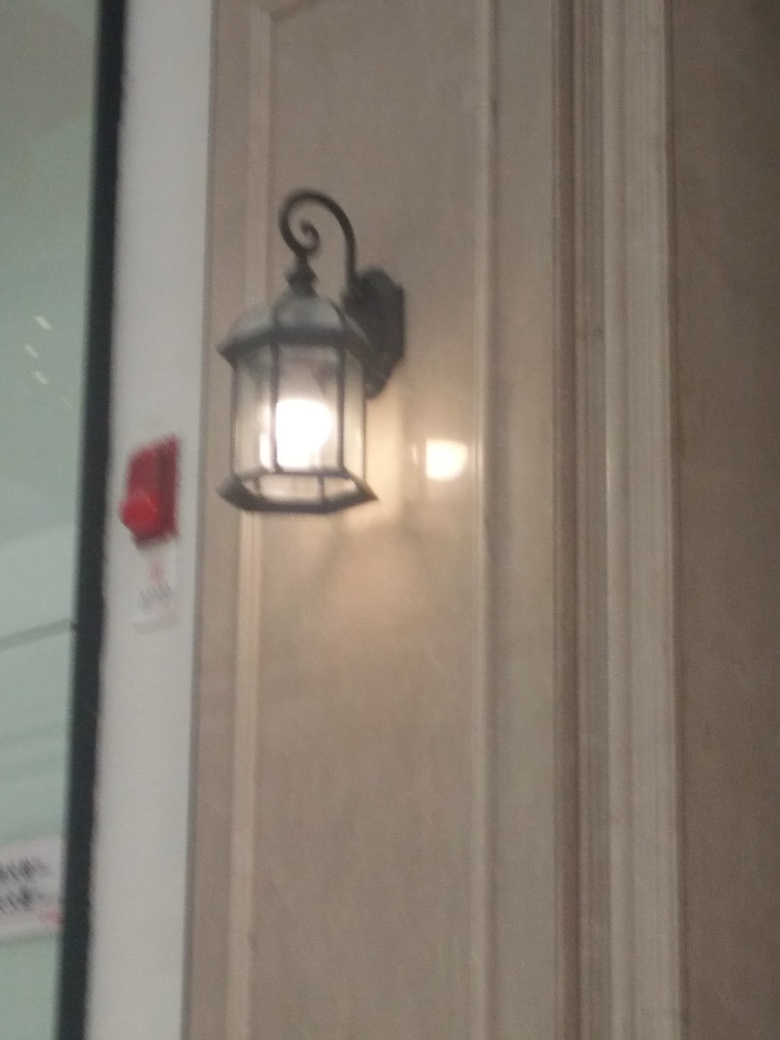What could be the setting or location where this lamp is installed? The lamp is mounted on a wall that appears to be part of a formal setting, possibly a corridor or exterior of a public building, or a sophisticated commercial area. The architecture suggests a setting that values classic aesthetics and possibly heritage. 